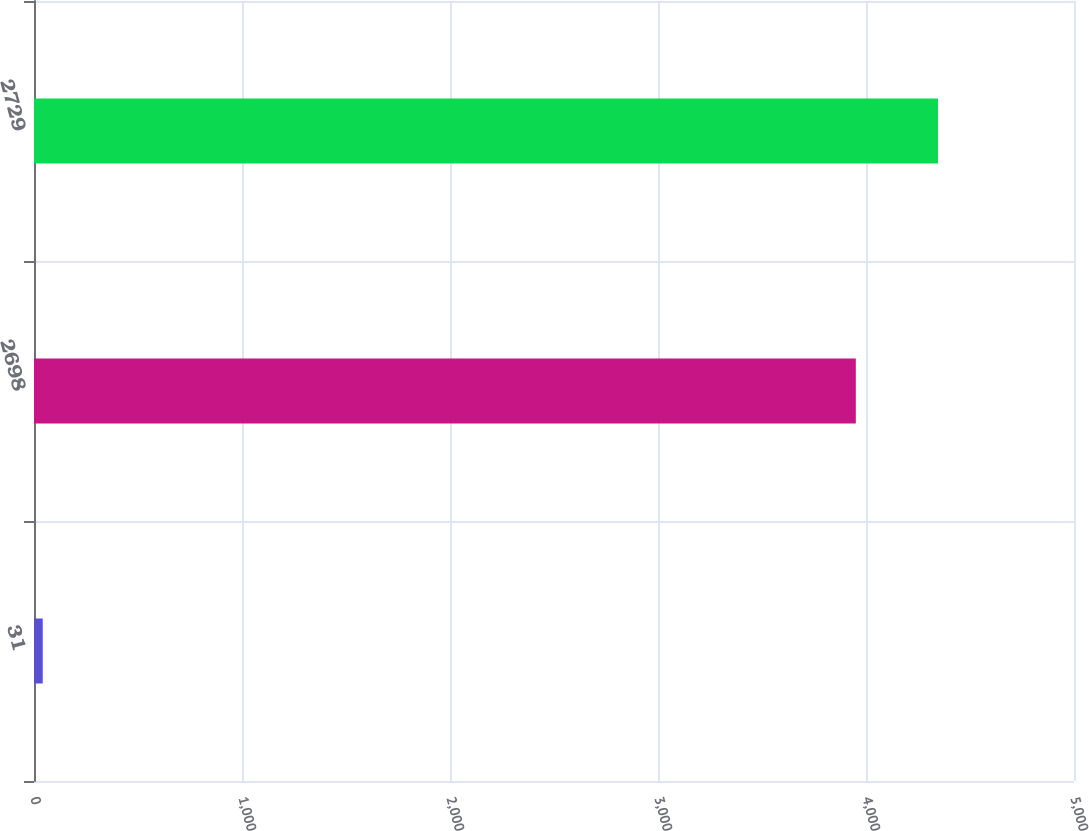Convert chart to OTSL. <chart><loc_0><loc_0><loc_500><loc_500><bar_chart><fcel>31<fcel>2698<fcel>2729<nl><fcel>42<fcel>3951<fcel>4346.1<nl></chart> 